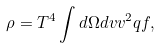<formula> <loc_0><loc_0><loc_500><loc_500>\rho = T ^ { 4 } \int d \Omega d v v ^ { 2 } q f ,</formula> 